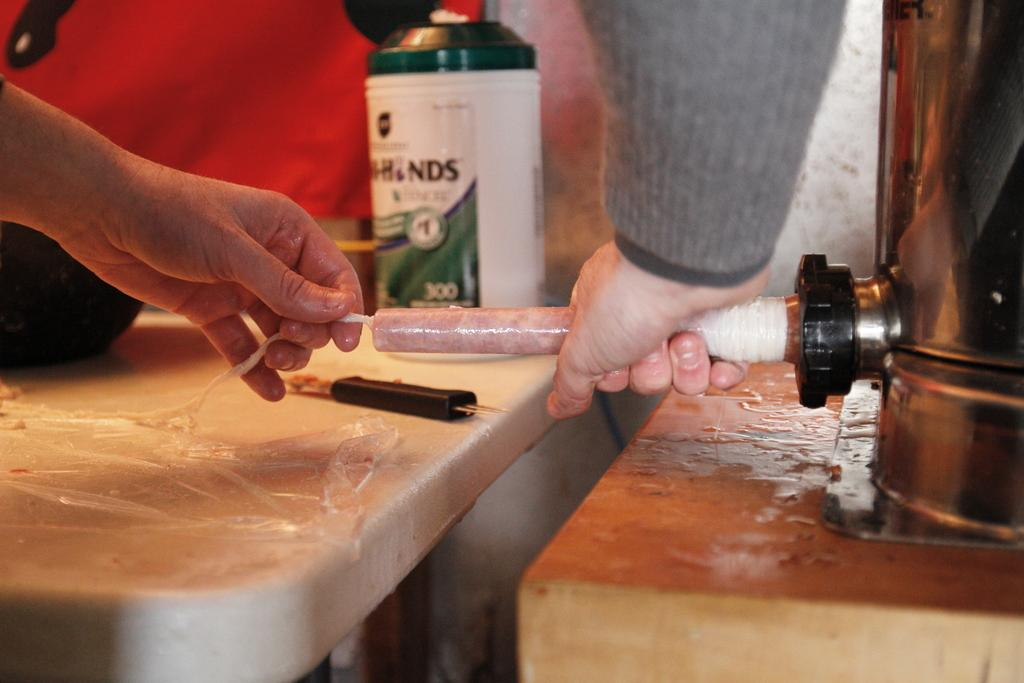<image>
Give a short and clear explanation of the subsequent image. a person putting a tube up to a machines with NDS in the back 